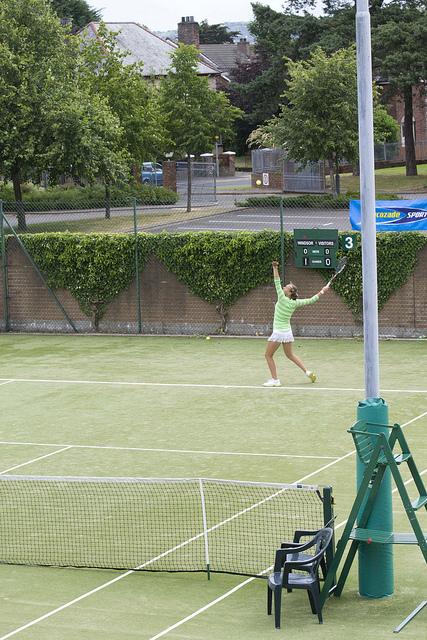What color is the chair?
Quick response, please. Green. What is the lady about to do?
Short answer required. Hit ball. Is this picture indoors?
Be succinct. No. 